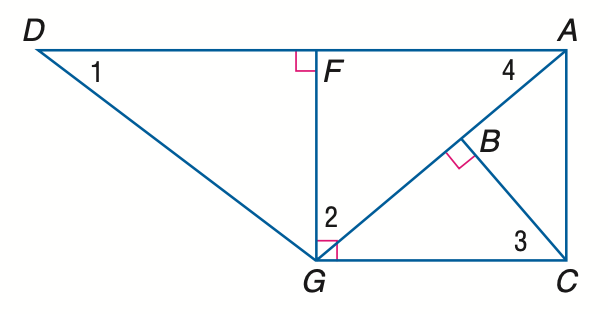Answer the mathemtical geometry problem and directly provide the correct option letter.
Question: Find the measure of \angle 3 if m \angle D G F = 53 and m \angle A G C = 40.
Choices: A: 40 B: 47 C: 50 D: 53 C 